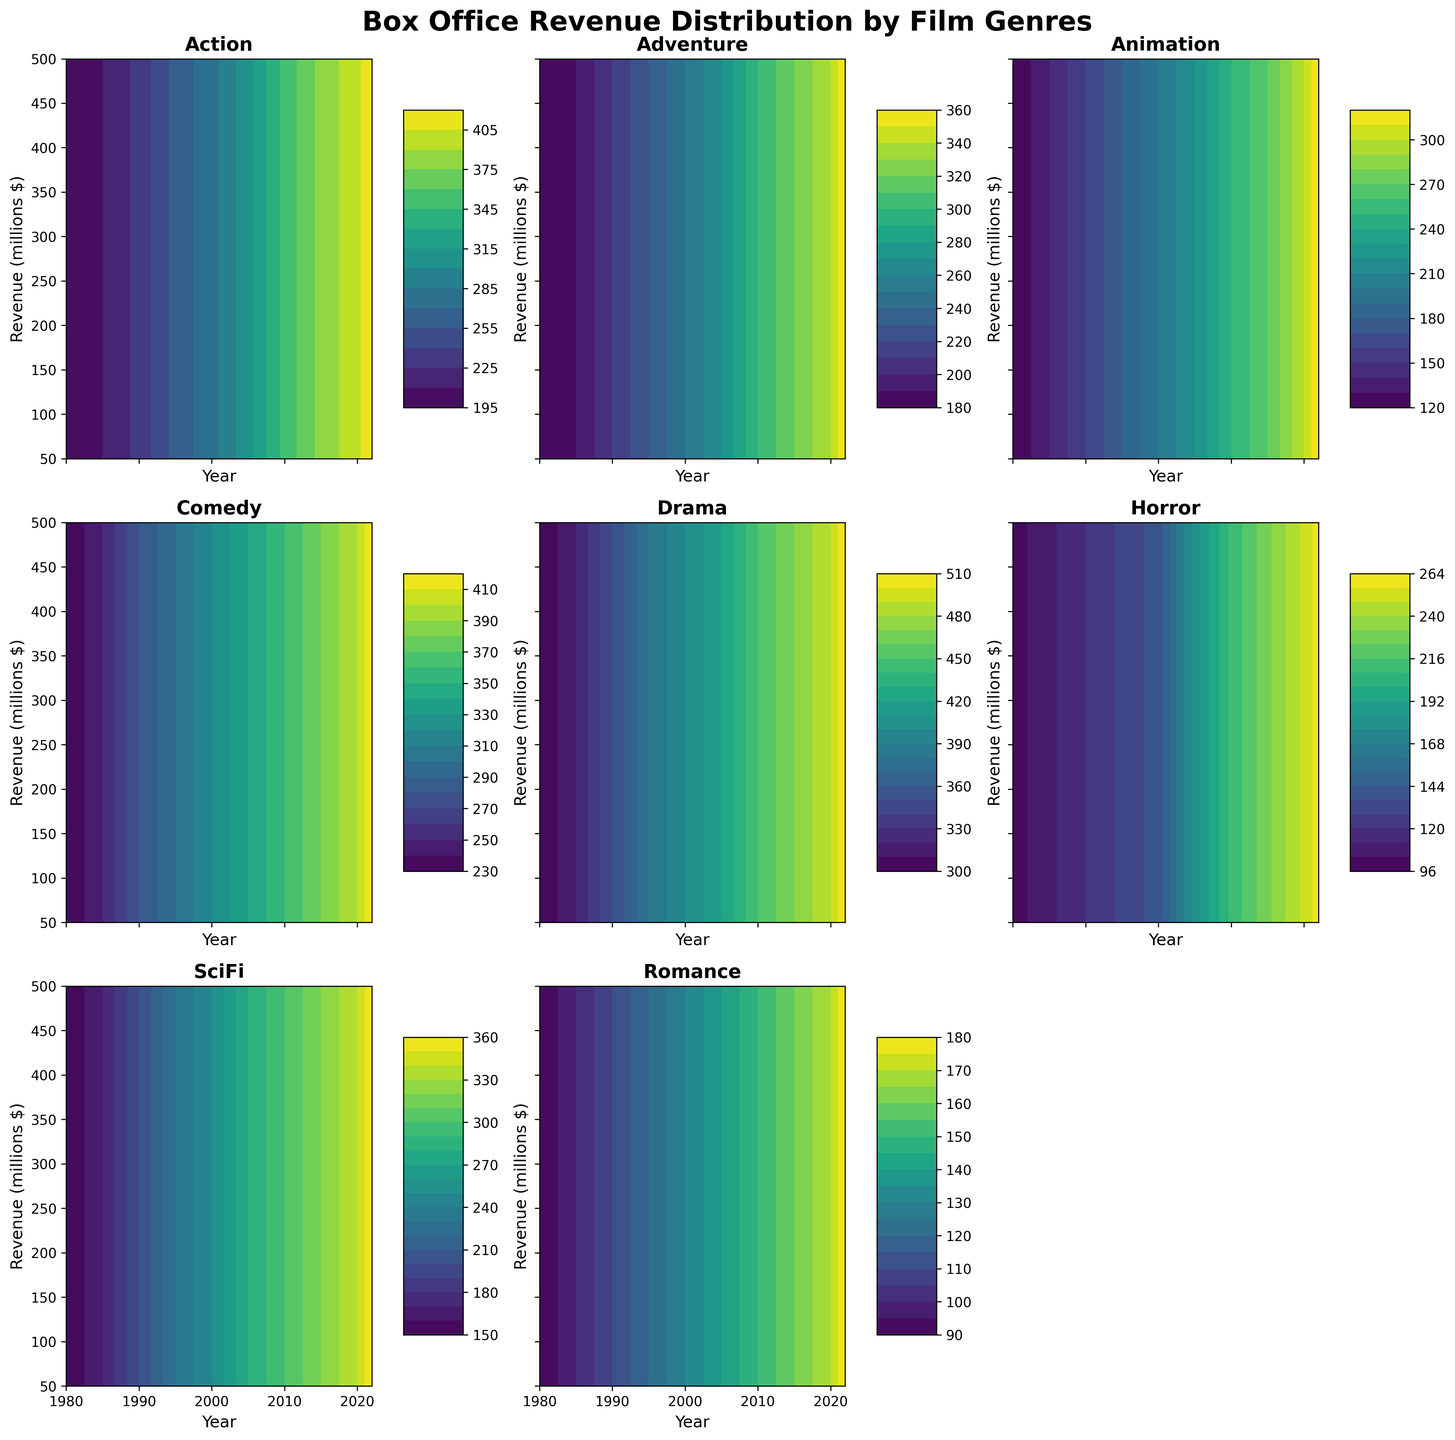What is the title of the figure? The title is located at the top center of the figure. It is written in bold and large font to stand out.
Answer: Box Office Revenue Distribution by Film Genres Which genre had the highest box office revenue in 2022? In the subplot titled "Drama", the contour lines indicate the highest revenue level among all genres in 2022.
Answer: Drama Based on the contour plots, which genre shows the most consistent increase in revenue over the years? The contour plots with evenly spaced and consistently ascending lines indicate steady increases. The Action genre plot shows this pattern clearly.
Answer: Action How does the box office revenue for Horror films in 2010 compare to that in 2000? Observing the contour levels in the subplot for Horror, we can see a significant increase from 200 million in 2000 to around 210 million in 2010.
Answer: The revenue increased by 10 million Which two genres had similar box office revenue trends from 2005 to 2020? Comparing the contour plots, both Horror and SciFi genres display similar growth patterns in revenue, with contours rising steadily, especially between 2005 and 2020.
Answer: Horror and SciFi What was the revenue range for Animation films in 2015? By looking at the contour plot for Animation in 2015, the revenue falls between contour lines representing 250 million and 270 million.
Answer: Between 250 and 270 million Which genre saw the least change in box office revenue from 2000 to 2020? The genre showing the least change will have closely spaced contour lines over the chosen years. The Romance genre has the least variation in its contour plot.
Answer: Romance Compare the popularity peaks for Comedy and Adventure films. In which year did each genre peak? The highest contour line peaks indicate popularity peaks. Comedy peaks around 2022, while Adventure also peaks close to that year.
Answer: Both peak around 2022 Which genre had the lowest box office revenue in 1980? By looking at the contour levels, the subplot for Romance shows the lowest revenue in 1980, around 90 million.
Answer: Romance 